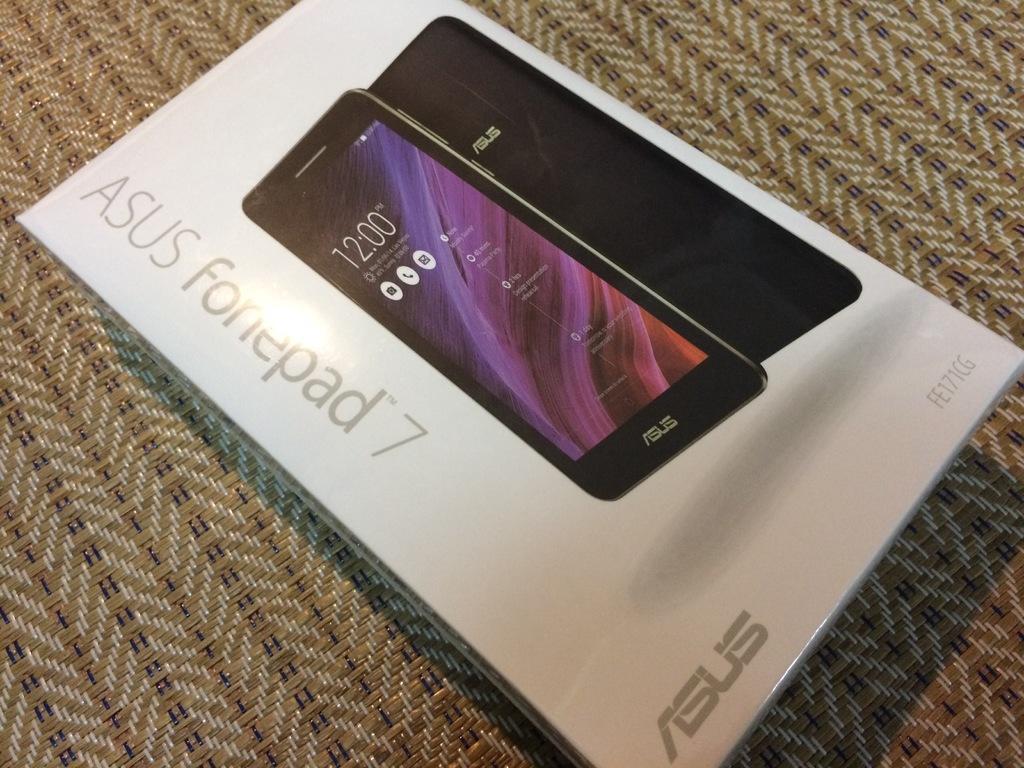What brand phone is shon?
Your answer should be compact. Asus. What model phone is this?
Ensure brevity in your answer.  Asus fonepad 7. 